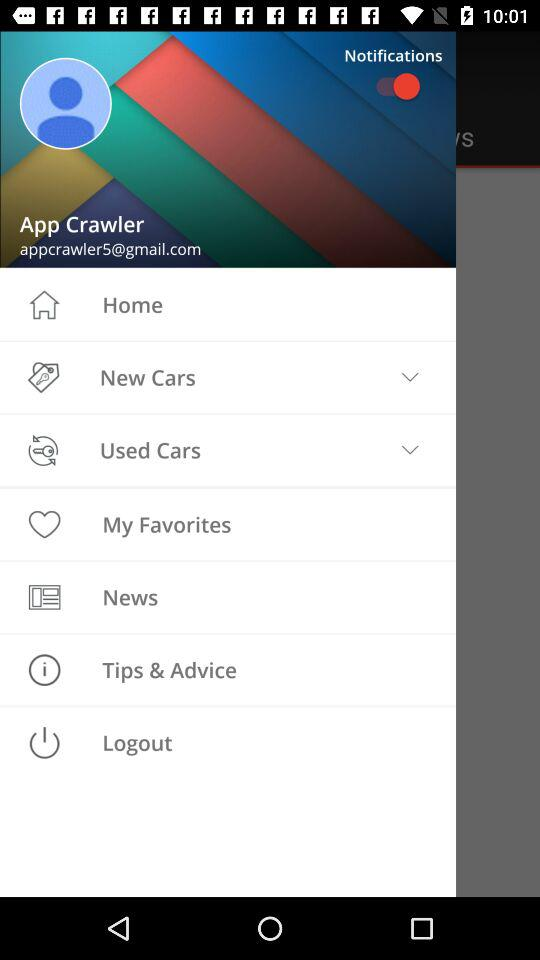What is the email address? The email address is appcrawler5@gmail.com. 